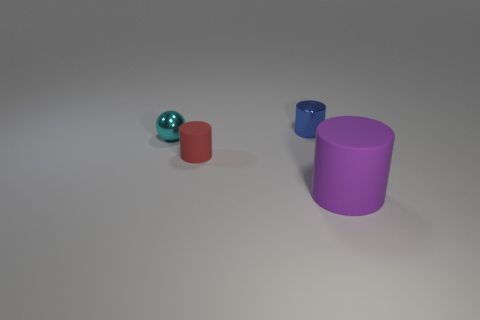What shape is the small shiny thing that is behind the cyan metallic ball?
Your answer should be compact. Cylinder. What is the color of the tiny thing that is left of the matte cylinder behind the purple rubber thing?
Keep it short and to the point. Cyan. What number of things are either matte things on the left side of the small blue metal cylinder or tiny metallic balls?
Make the answer very short. 2. Is the size of the red thing the same as the cylinder to the right of the blue metal cylinder?
Offer a very short reply. No. How many large objects are blue cylinders or matte things?
Offer a very short reply. 1. What is the shape of the tiny blue metallic thing?
Make the answer very short. Cylinder. Are there any tiny cyan spheres made of the same material as the blue cylinder?
Offer a terse response. Yes. Are there more red matte cylinders than purple matte blocks?
Give a very brief answer. Yes. Is the tiny red cylinder made of the same material as the blue cylinder?
Ensure brevity in your answer.  No. How many matte things are purple cylinders or small things?
Make the answer very short. 2. 